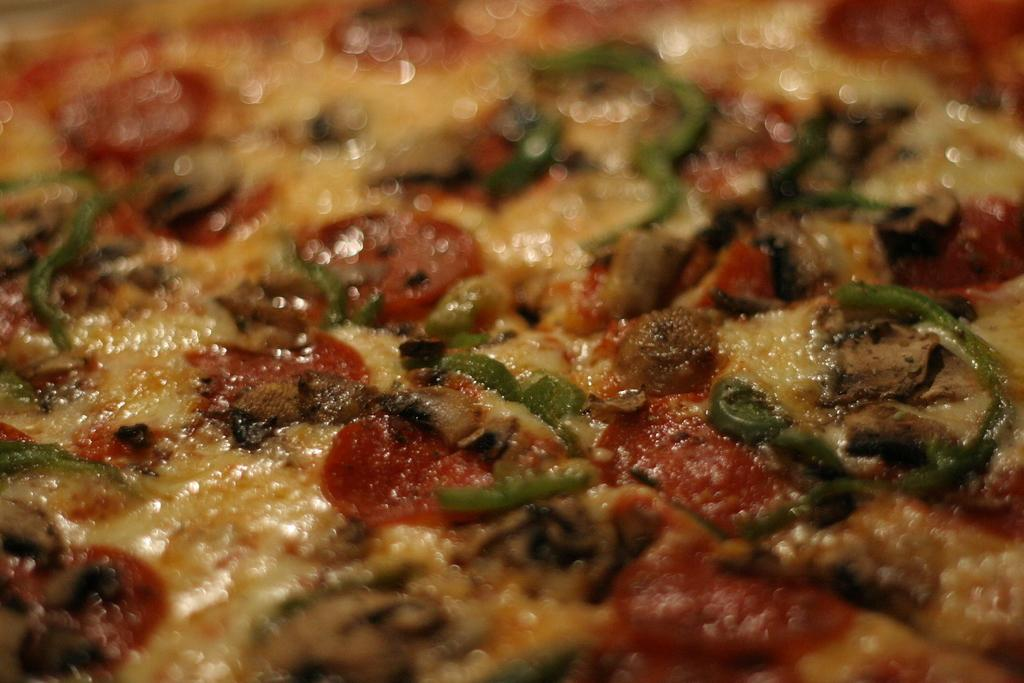What type of food is the main subject of the image? There is a pizza in the image. What colors are visible on the pizza? The pizza has yellow and red colors. What ingredient is present on the pizza? There is cheese on the pizza. Can you describe the background of the image? The background of the image is blurred. Where is the scarecrow standing in the image? There is no scarecrow present in the image. What type of grass can be seen growing around the pizza? There is no grass visible in the image; it only features a pizza with a blurred background. 